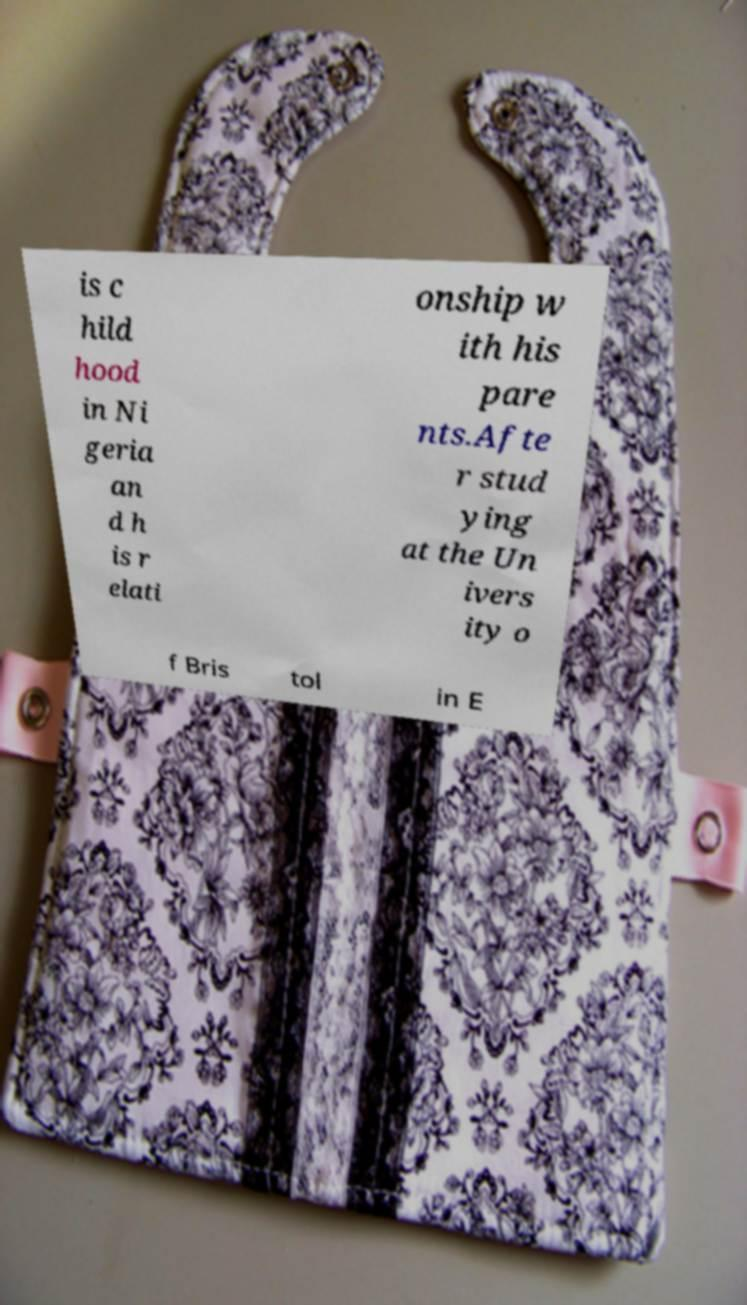I need the written content from this picture converted into text. Can you do that? is c hild hood in Ni geria an d h is r elati onship w ith his pare nts.Afte r stud ying at the Un ivers ity o f Bris tol in E 